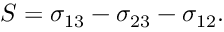Convert formula to latex. <formula><loc_0><loc_0><loc_500><loc_500>S = \sigma _ { 1 3 } - \sigma _ { 2 3 } - \sigma _ { 1 2 } .</formula> 